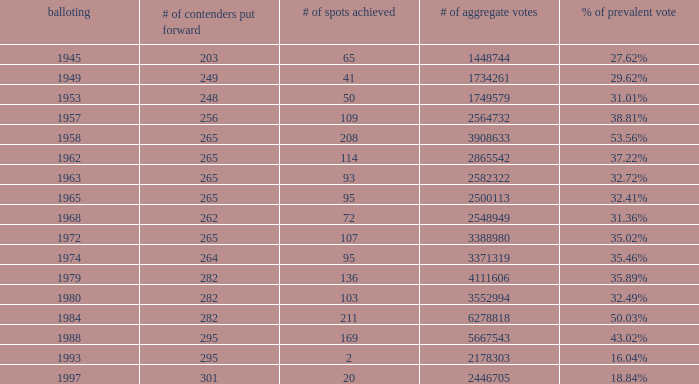What year was the election when the # of seats won was 65? 1945.0. 